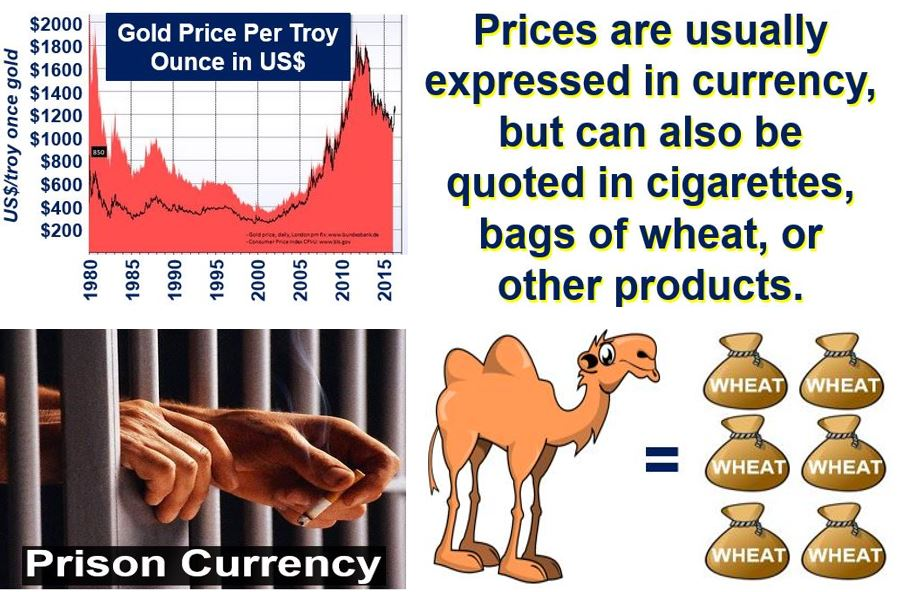Based on the image, construct a realistic short scenario in which wheat is used as currency. In a small, remote prison where traditional money is not in circulation, wheat becomes a valuable currency. The prison kitchen occasionally receives shipments of wheat, which is then traded among inmates for favors or other goods. One inmate, known for hoarding wheat, uses it to obtain scarce items like extra blankets or contraband. Over time, wheat becomes so commonplace in trade that a standardized bartering system develops: one handful of wheat for a bar of soap, three handfuls for a pack of cigarettes, and so on. This informal economy thrives, creating a sense of community and an alternative means of survival within the prison walls. 